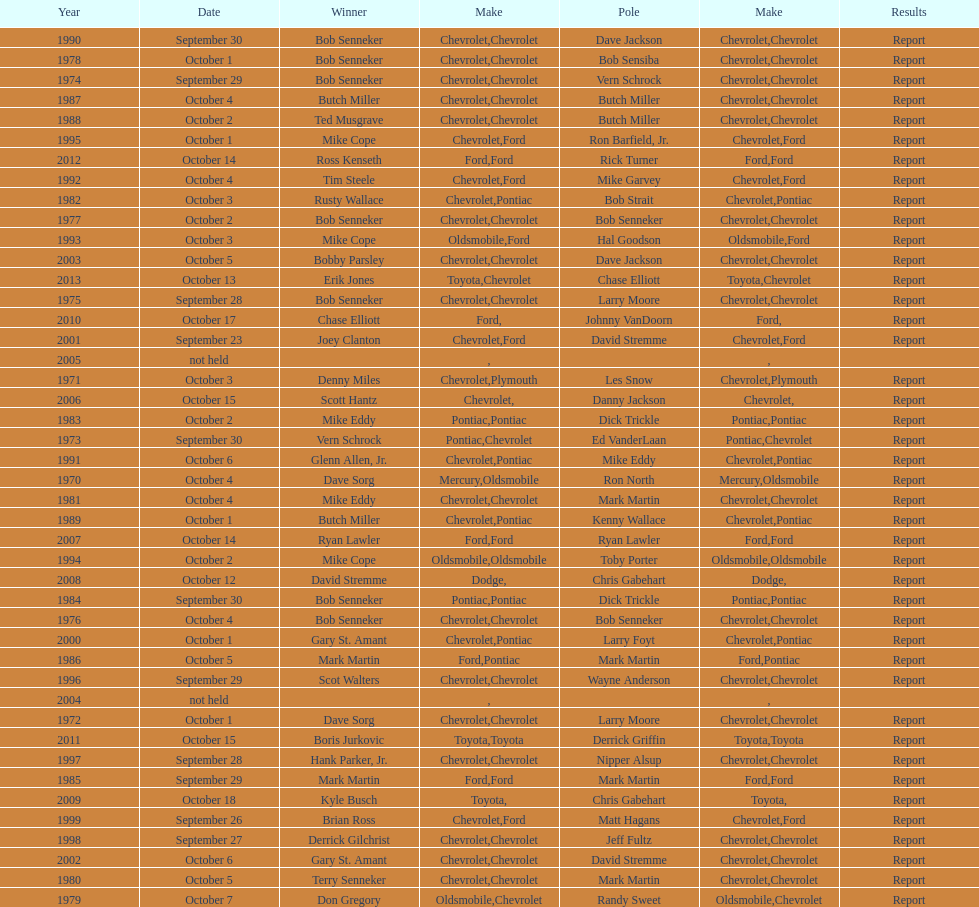How many consecutive wins did bob senneker have? 5. 